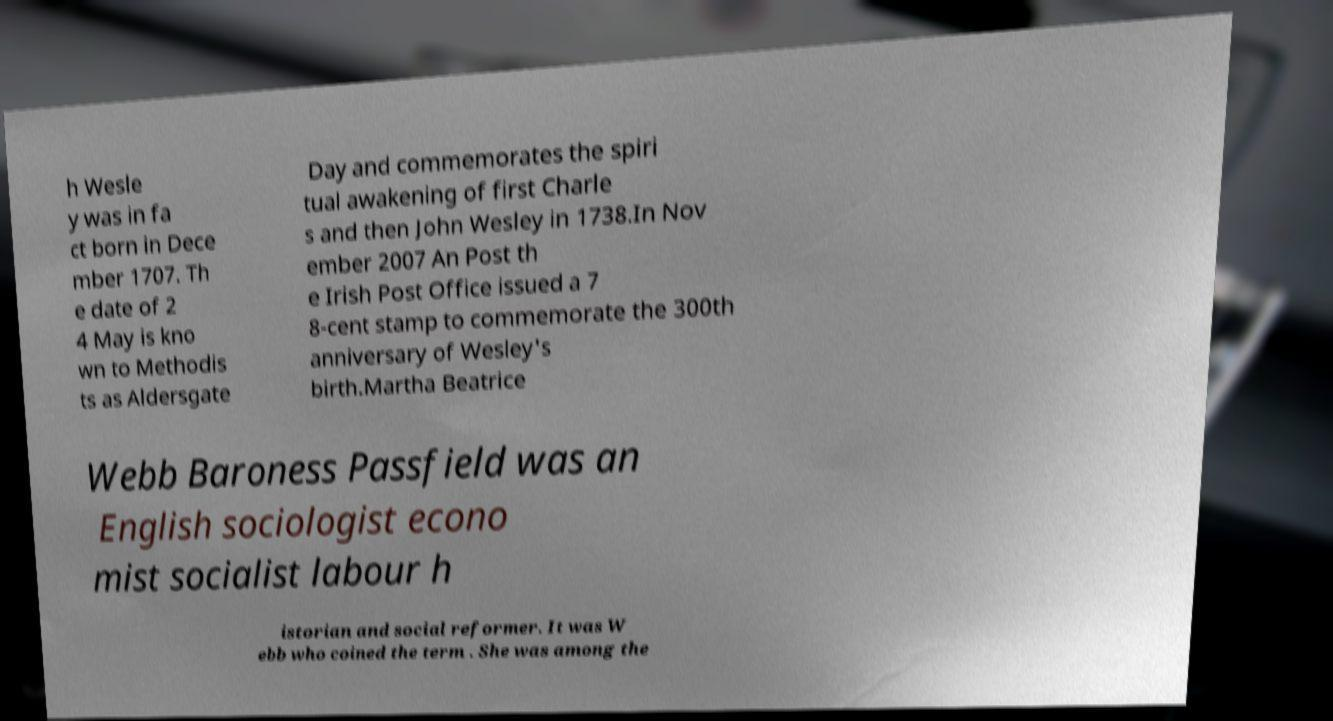Could you assist in decoding the text presented in this image and type it out clearly? h Wesle y was in fa ct born in Dece mber 1707. Th e date of 2 4 May is kno wn to Methodis ts as Aldersgate Day and commemorates the spiri tual awakening of first Charle s and then John Wesley in 1738.In Nov ember 2007 An Post th e Irish Post Office issued a 7 8-cent stamp to commemorate the 300th anniversary of Wesley's birth.Martha Beatrice Webb Baroness Passfield was an English sociologist econo mist socialist labour h istorian and social reformer. It was W ebb who coined the term . She was among the 